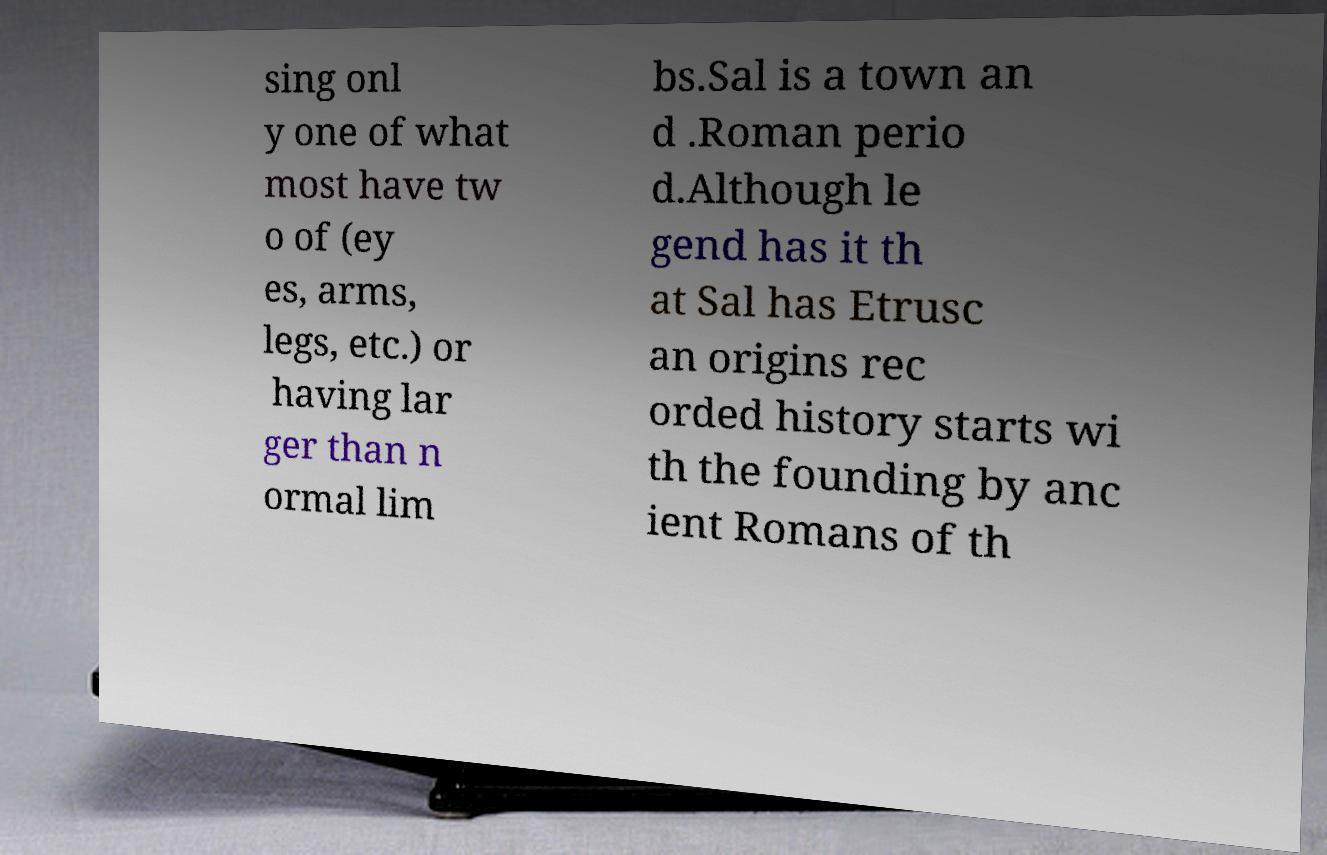For documentation purposes, I need the text within this image transcribed. Could you provide that? sing onl y one of what most have tw o of (ey es, arms, legs, etc.) or having lar ger than n ormal lim bs.Sal is a town an d .Roman perio d.Although le gend has it th at Sal has Etrusc an origins rec orded history starts wi th the founding by anc ient Romans of th 